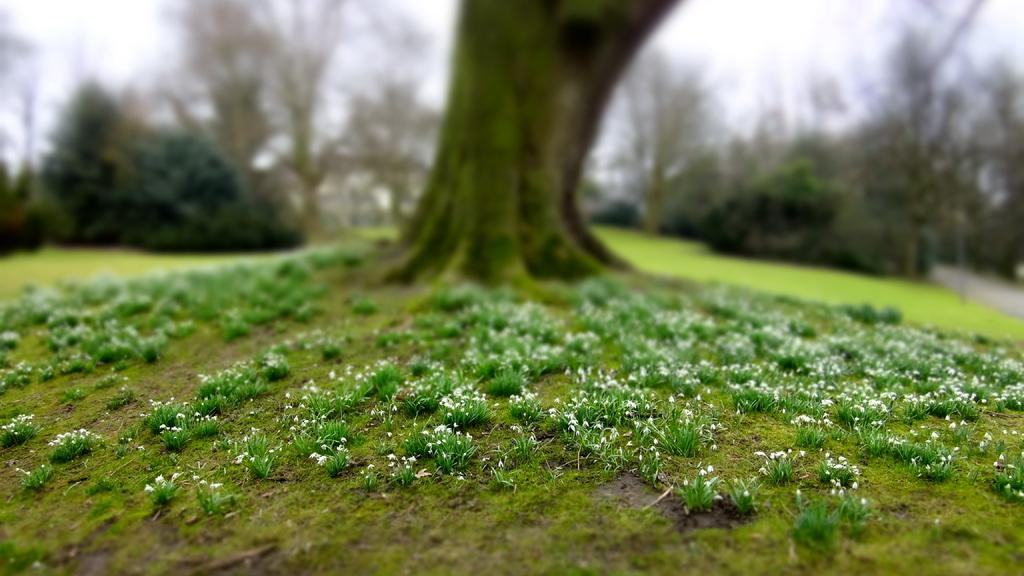What type of vegetation can be seen in the image? There are trees in the image. What is covering the ground in the image? There is grass on the ground in the image. How many pizzas are being sold at the store in the image? There is no store or pizzas present in the image; it features trees and grass. 